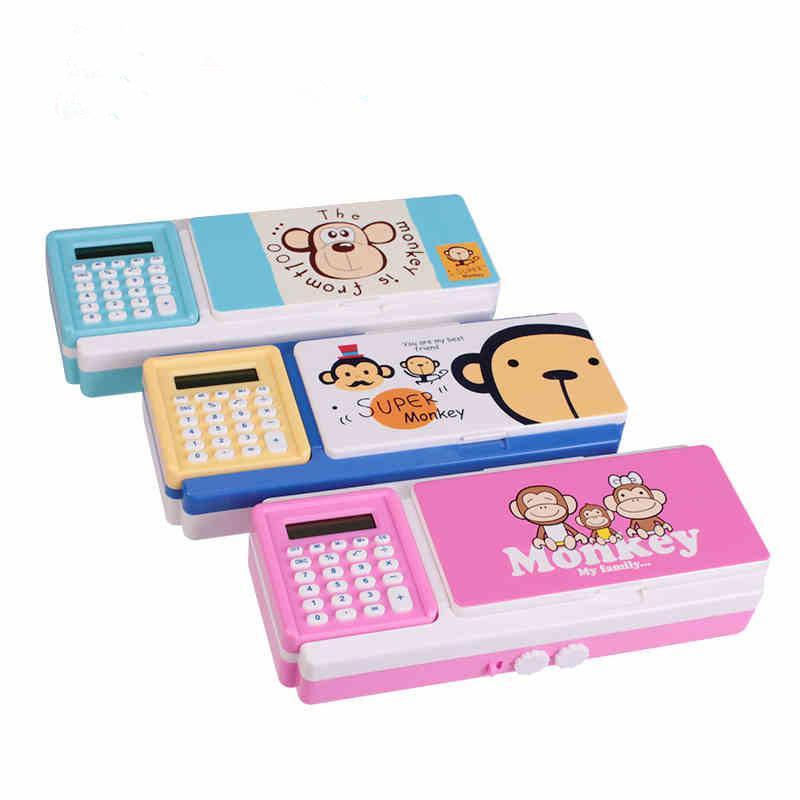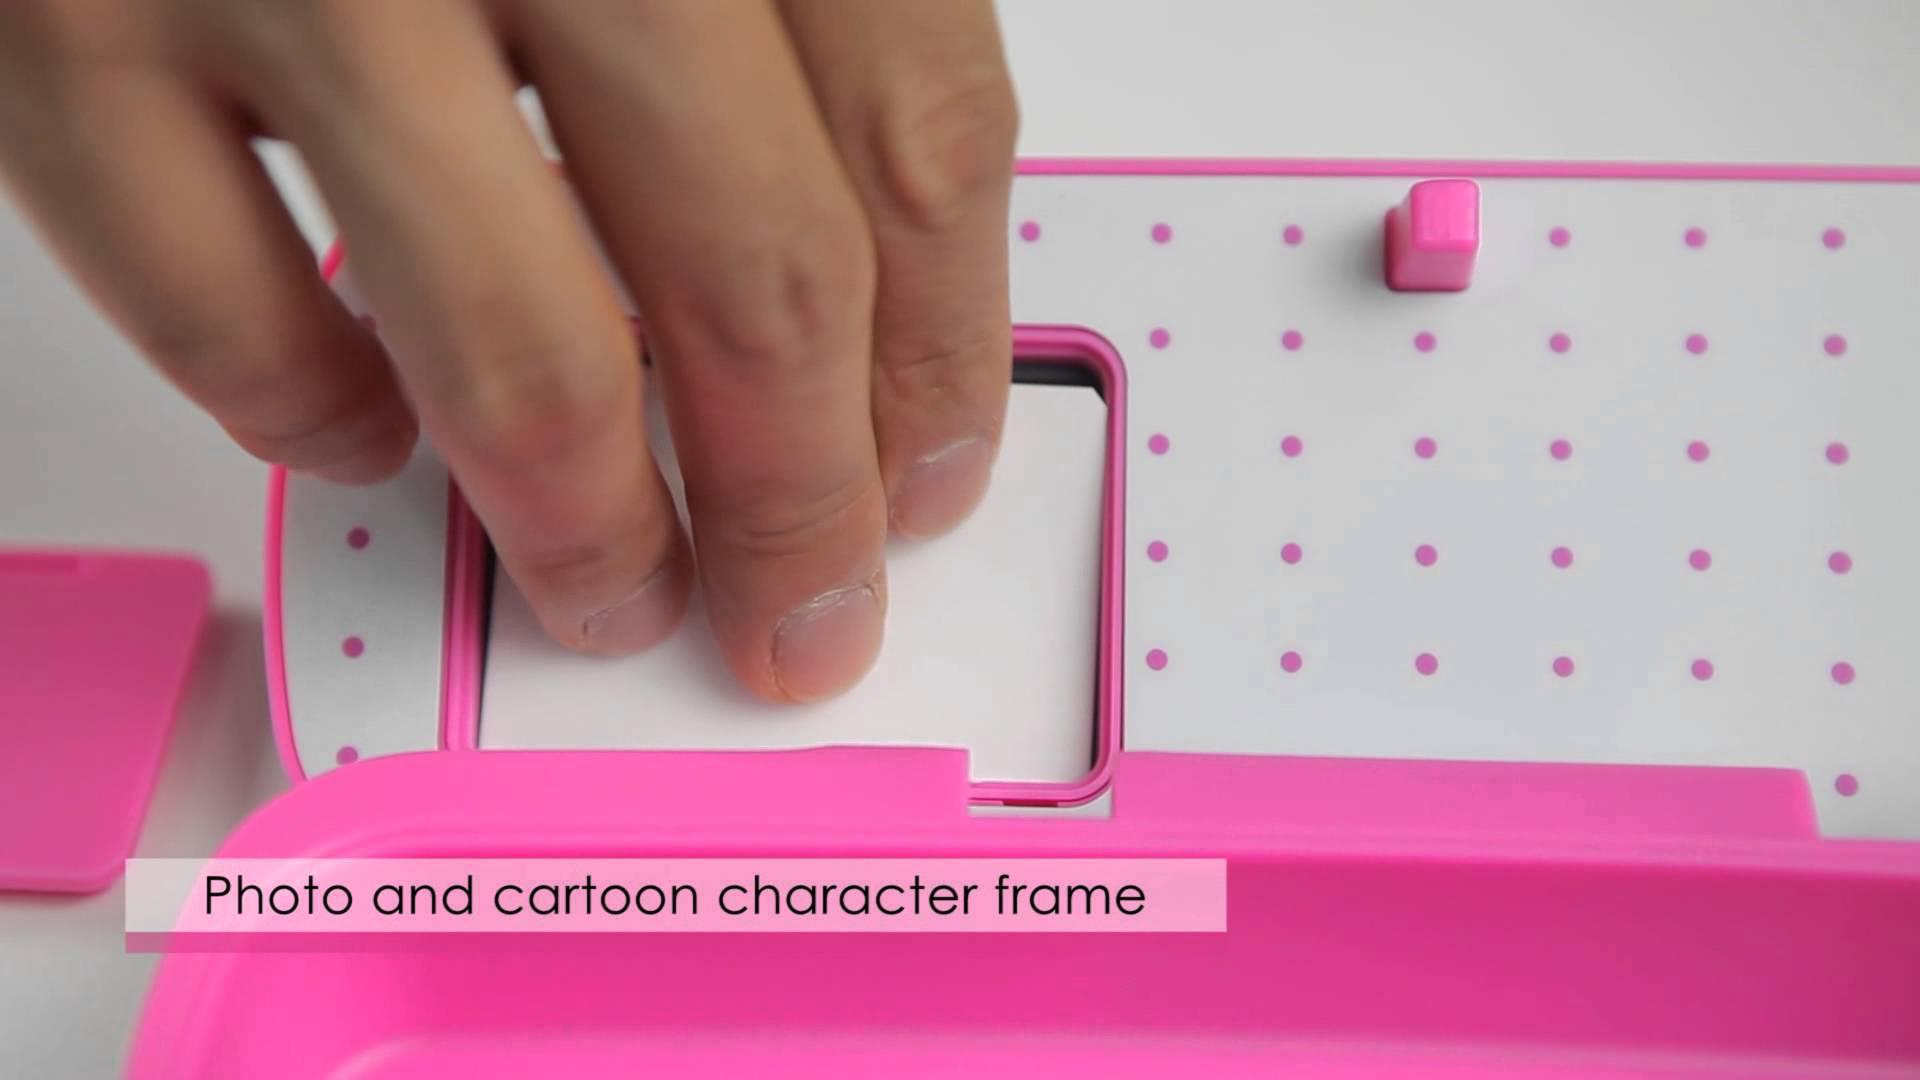The first image is the image on the left, the second image is the image on the right. For the images shown, is this caption "Both of the cases is opened to reveal their items." true? Answer yes or no. No. The first image is the image on the left, the second image is the image on the right. Assess this claim about the two images: "The right image contains a pencil holder that has a small drawer in the middle that is pulled out.". Correct or not? Answer yes or no. No. 